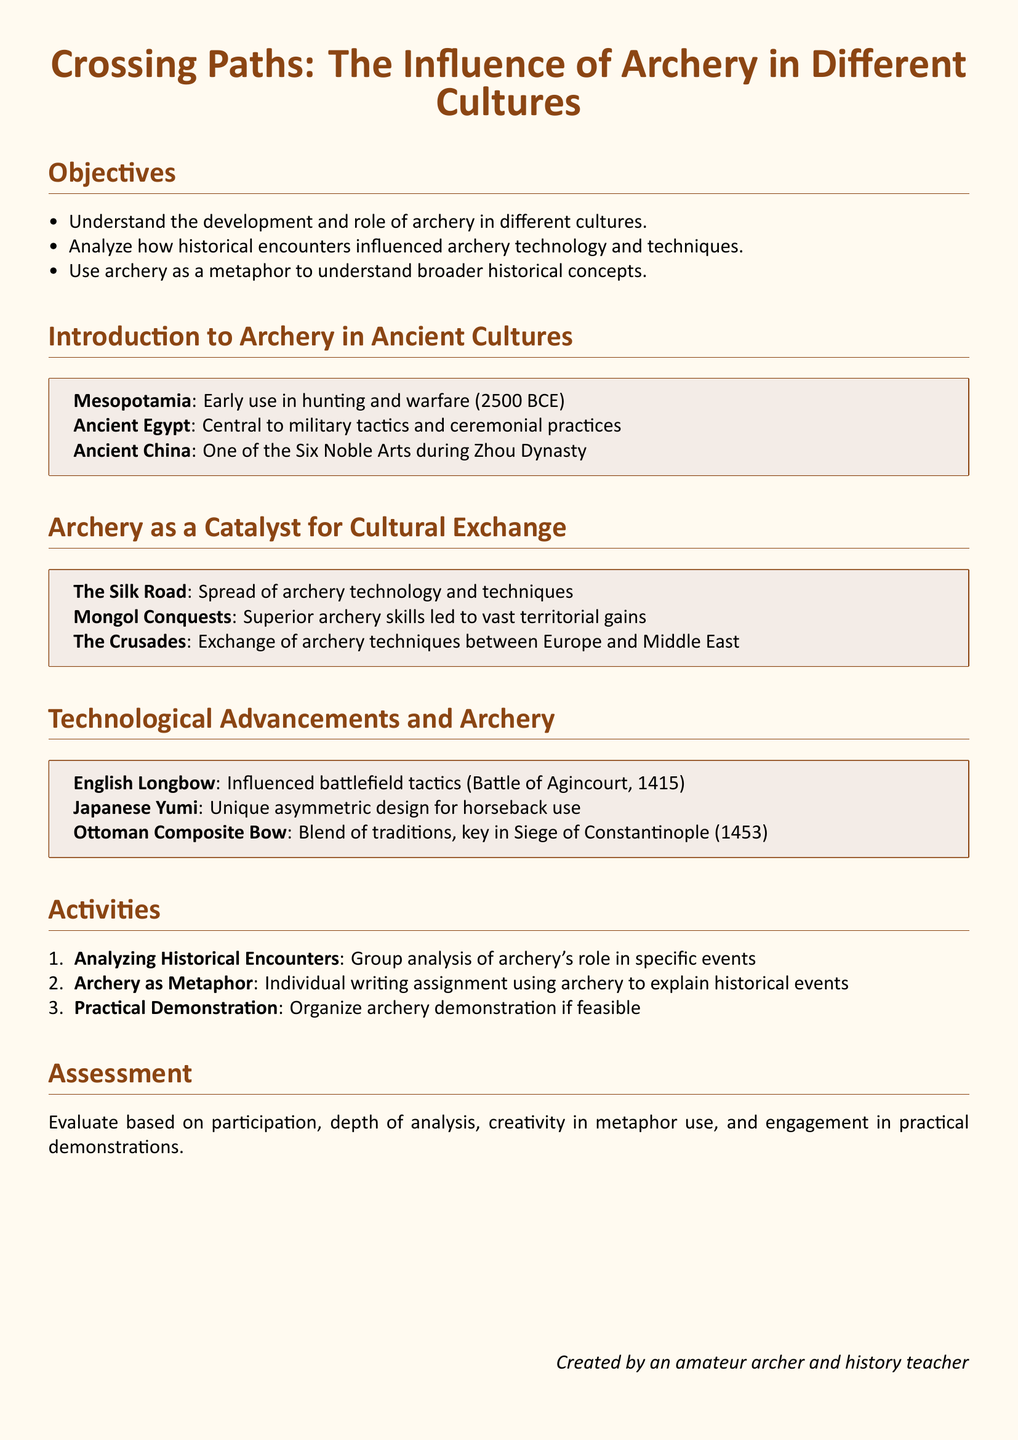What is the title of the lesson plan? The title of the lesson plan is stated at the beginning of the document.
Answer: Crossing Paths: The Influence of Archery in Different Cultures What year marks the early use of archery in Mesopotamia? The document specifies a date for the early use of archery in Mesopotamia.
Answer: 2500 BCE What was one of the Six Noble Arts in Ancient China? The document lists archery as a significant discipline in Ancient China.
Answer: Archery Which battle is associated with the influence of the English Longbow? The document mentions a specific historical battle related to the English Longbow.
Answer: Battle of Agincourt What event led to the exchange of archery techniques between Europe and the Middle East? The document outlines an important historical event linked to cultural exchange in archery.
Answer: The Crusades Which cultural item is described as having a unique asymmetric design for horseback use? The document describes a specific type of bow with a distinctive characteristic.
Answer: Japanese Yumi How many activities are listed in the lesson plan? The document enumerates specific activities under a designated section.
Answer: 3 What method will be used for assessment in the lesson plan? The document describes the criteria for evaluating student performance.
Answer: Participation, depth of analysis, creativity in metaphor use, and engagement in practical demonstrations 